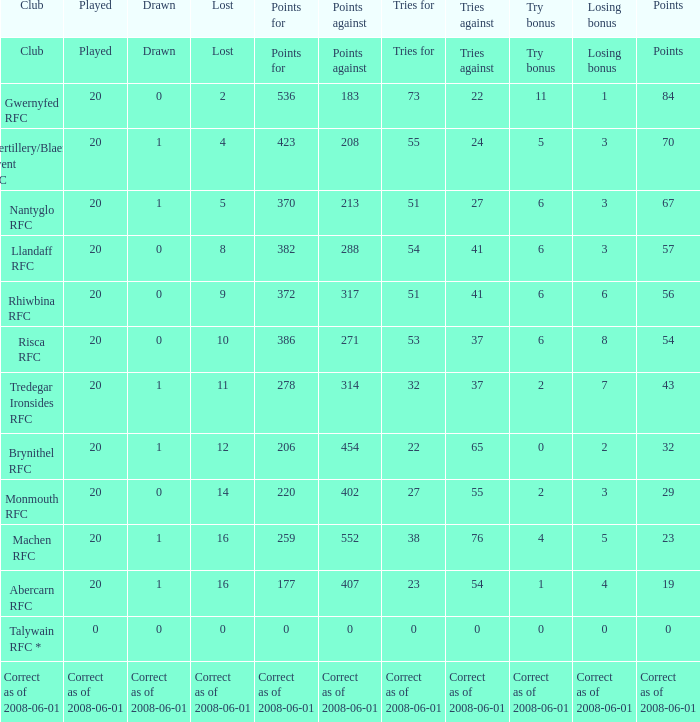What's the try bonus that had 423 points? 5.0. 